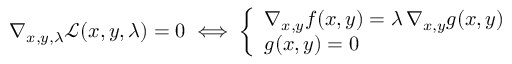<formula> <loc_0><loc_0><loc_500><loc_500>\nabla _ { x , y , \lambda } { \mathcal { L } } ( x , y , \lambda ) = 0 \iff { \left \{ \begin{array} { l l } { \nabla _ { x , y } f ( x , y ) = \lambda \, \nabla _ { x , y } g ( x , y ) } \\ { g ( x , y ) = 0 } \end{array} }</formula> 